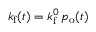Convert formula to latex. <formula><loc_0><loc_0><loc_500><loc_500>k _ { f } ( t ) = k _ { f } ^ { 0 } \, p _ { o } ( t )</formula> 